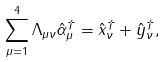<formula> <loc_0><loc_0><loc_500><loc_500>\sum _ { \mu = 1 } ^ { 4 } \Lambda _ { \mu \nu } \hat { \alpha } _ { \mu } ^ { \dagger } = \hat { x } _ { \nu } ^ { \dagger } + \hat { y } _ { \nu } ^ { \dagger } ,</formula> 